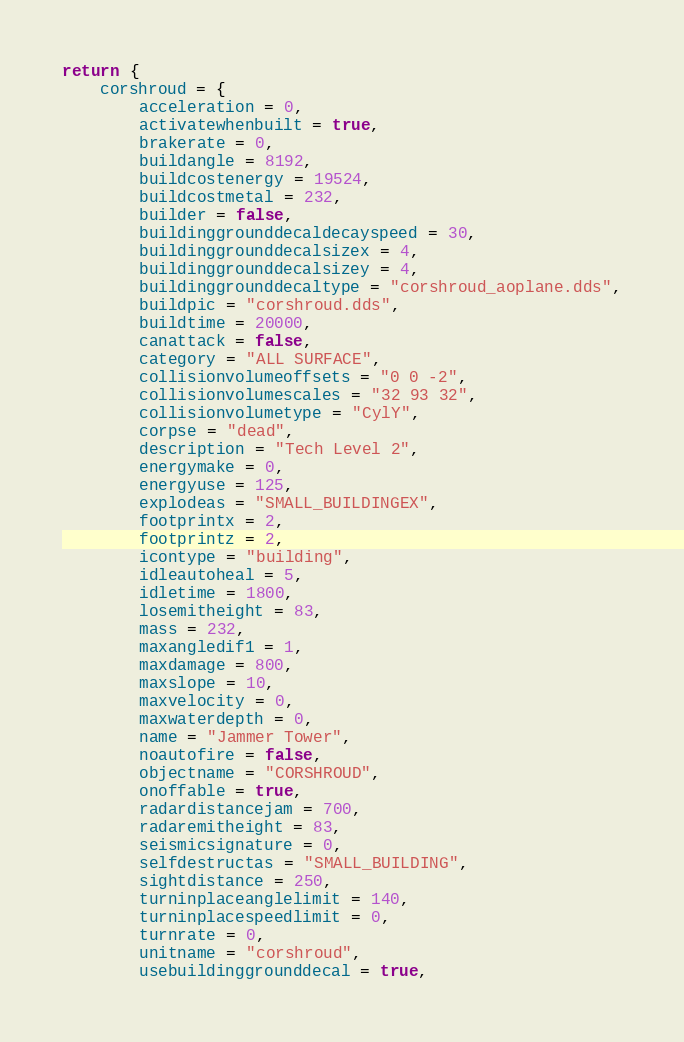Convert code to text. <code><loc_0><loc_0><loc_500><loc_500><_Lua_>return {
	corshroud = {
		acceleration = 0,
		activatewhenbuilt = true,
		brakerate = 0,
		buildangle = 8192,
		buildcostenergy = 19524,
		buildcostmetal = 232,
		builder = false,
		buildinggrounddecaldecayspeed = 30,
		buildinggrounddecalsizex = 4,
		buildinggrounddecalsizey = 4,
		buildinggrounddecaltype = "corshroud_aoplane.dds",
		buildpic = "corshroud.dds",
		buildtime = 20000,
		canattack = false,
		category = "ALL SURFACE",
		collisionvolumeoffsets = "0 0 -2",
		collisionvolumescales = "32 93 32",
		collisionvolumetype = "CylY",
		corpse = "dead",
		description = "Tech Level 2",
		energymake = 0,
		energyuse = 125,
		explodeas = "SMALL_BUILDINGEX",
		footprintx = 2,
		footprintz = 2,
		icontype = "building",
		idleautoheal = 5,
		idletime = 1800,
		losemitheight = 83,
		mass = 232,
		maxangledif1 = 1,
		maxdamage = 800,
		maxslope = 10,
		maxvelocity = 0,
		maxwaterdepth = 0,
		name = "Jammer Tower",
		noautofire = false,		
		objectname = "CORSHROUD",
		onoffable = true,
		radardistancejam = 700,
		radaremitheight = 83,
		seismicsignature = 0,
		selfdestructas = "SMALL_BUILDING",
		sightdistance = 250,
		turninplaceanglelimit = 140,
		turninplacespeedlimit = 0,
		turnrate = 0,
		unitname = "corshroud",
		usebuildinggrounddecal = true,</code> 